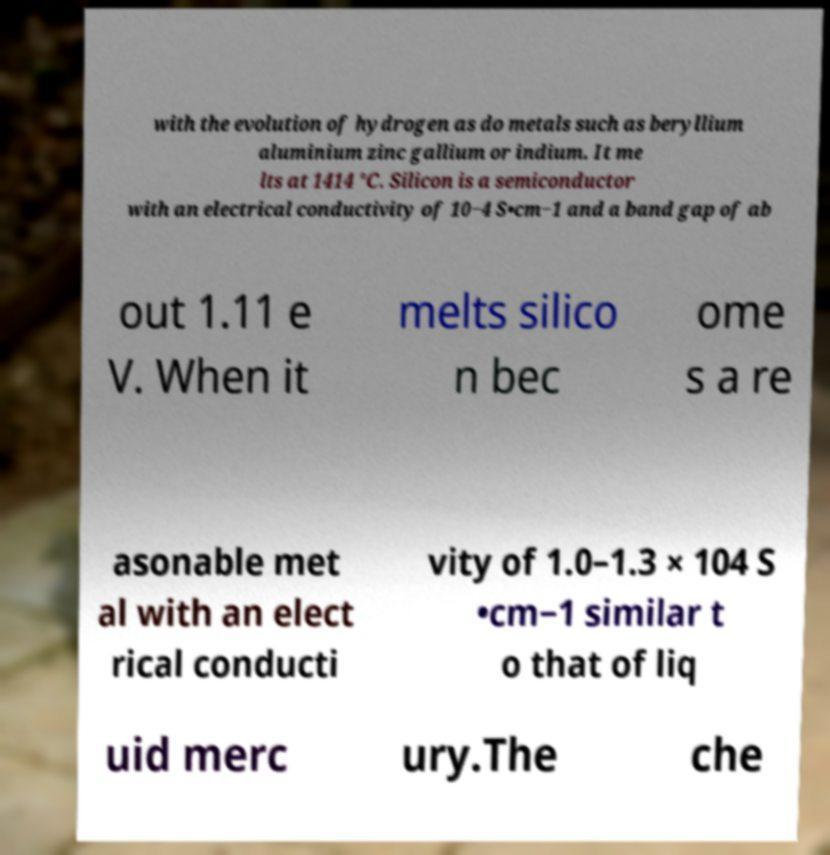Could you assist in decoding the text presented in this image and type it out clearly? with the evolution of hydrogen as do metals such as beryllium aluminium zinc gallium or indium. It me lts at 1414 °C. Silicon is a semiconductor with an electrical conductivity of 10−4 S•cm−1 and a band gap of ab out 1.11 e V. When it melts silico n bec ome s a re asonable met al with an elect rical conducti vity of 1.0–1.3 × 104 S •cm−1 similar t o that of liq uid merc ury.The che 